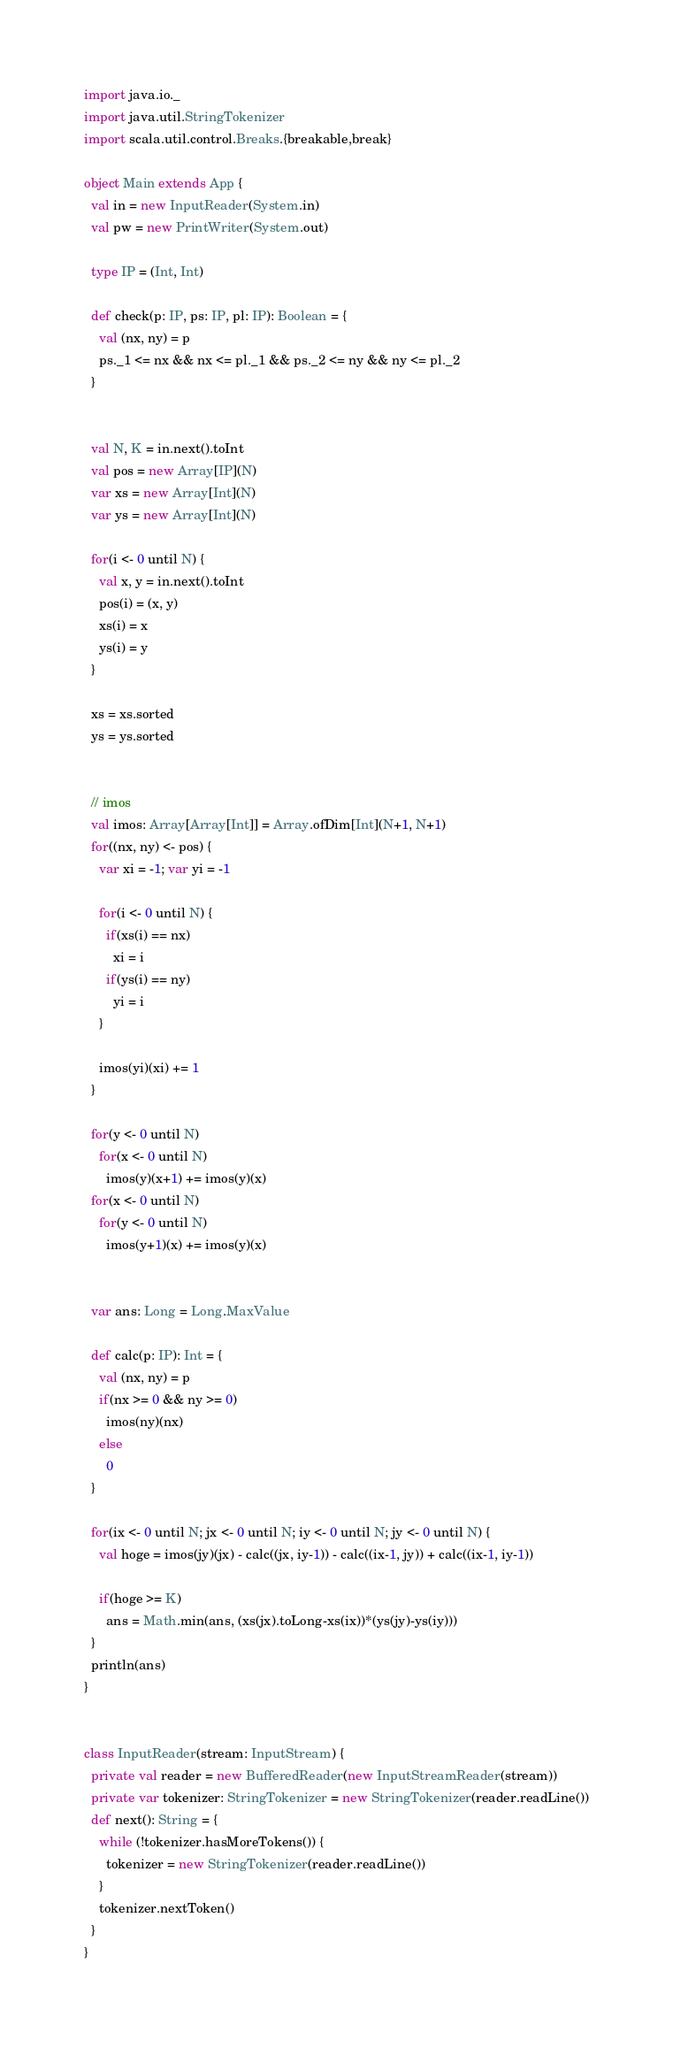Convert code to text. <code><loc_0><loc_0><loc_500><loc_500><_Scala_>import java.io._
import java.util.StringTokenizer
import scala.util.control.Breaks.{breakable,break}

object Main extends App {
  val in = new InputReader(System.in)
  val pw = new PrintWriter(System.out)

  type IP = (Int, Int)

  def check(p: IP, ps: IP, pl: IP): Boolean = {
    val (nx, ny) = p
    ps._1 <= nx && nx <= pl._1 && ps._2 <= ny && ny <= pl._2
  }


  val N, K = in.next().toInt
  val pos = new Array[IP](N)
  var xs = new Array[Int](N)
  var ys = new Array[Int](N)

  for(i <- 0 until N) {
    val x, y = in.next().toInt
    pos(i) = (x, y)
    xs(i) = x
    ys(i) = y
  }

  xs = xs.sorted
  ys = ys.sorted


  // imos
  val imos: Array[Array[Int]] = Array.ofDim[Int](N+1, N+1)
  for((nx, ny) <- pos) {
    var xi = -1; var yi = -1

    for(i <- 0 until N) {
      if(xs(i) == nx)
        xi = i
      if(ys(i) == ny)
        yi = i
    }

    imos(yi)(xi) += 1
  }

  for(y <- 0 until N)
    for(x <- 0 until N)
      imos(y)(x+1) += imos(y)(x)
  for(x <- 0 until N)
    for(y <- 0 until N)
      imos(y+1)(x) += imos(y)(x)


  var ans: Long = Long.MaxValue

  def calc(p: IP): Int = {
    val (nx, ny) = p
    if(nx >= 0 && ny >= 0)
      imos(ny)(nx)
    else
      0
  }

  for(ix <- 0 until N; jx <- 0 until N; iy <- 0 until N; jy <- 0 until N) {
    val hoge = imos(jy)(jx) - calc((jx, iy-1)) - calc((ix-1, jy)) + calc((ix-1, iy-1))

    if(hoge >= K)
      ans = Math.min(ans, (xs(jx).toLong-xs(ix))*(ys(jy)-ys(iy)))
  }
  println(ans)
}


class InputReader(stream: InputStream) {
  private val reader = new BufferedReader(new InputStreamReader(stream))
  private var tokenizer: StringTokenizer = new StringTokenizer(reader.readLine())
  def next(): String = {
    while (!tokenizer.hasMoreTokens()) {
      tokenizer = new StringTokenizer(reader.readLine())
    }
    tokenizer.nextToken()
  }
}
</code> 